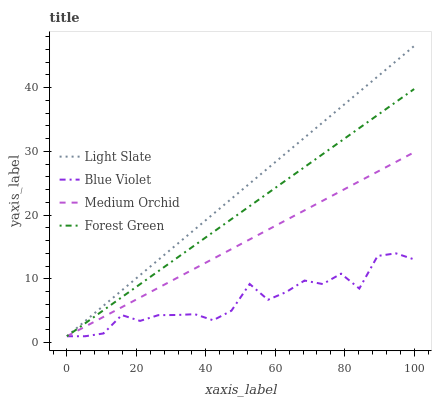Does Blue Violet have the minimum area under the curve?
Answer yes or no. Yes. Does Light Slate have the maximum area under the curve?
Answer yes or no. Yes. Does Forest Green have the minimum area under the curve?
Answer yes or no. No. Does Forest Green have the maximum area under the curve?
Answer yes or no. No. Is Medium Orchid the smoothest?
Answer yes or no. Yes. Is Blue Violet the roughest?
Answer yes or no. Yes. Is Forest Green the smoothest?
Answer yes or no. No. Is Forest Green the roughest?
Answer yes or no. No. Does Light Slate have the lowest value?
Answer yes or no. Yes. Does Light Slate have the highest value?
Answer yes or no. Yes. Does Forest Green have the highest value?
Answer yes or no. No. Does Light Slate intersect Medium Orchid?
Answer yes or no. Yes. Is Light Slate less than Medium Orchid?
Answer yes or no. No. Is Light Slate greater than Medium Orchid?
Answer yes or no. No. 